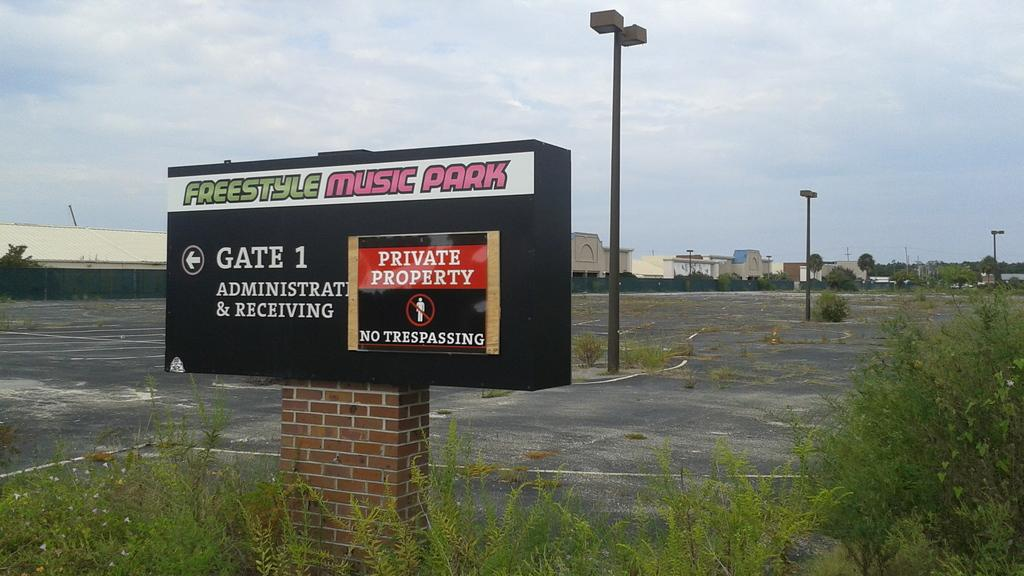<image>
Present a compact description of the photo's key features. A sign for Freestyle Music Park notes it is private property. 